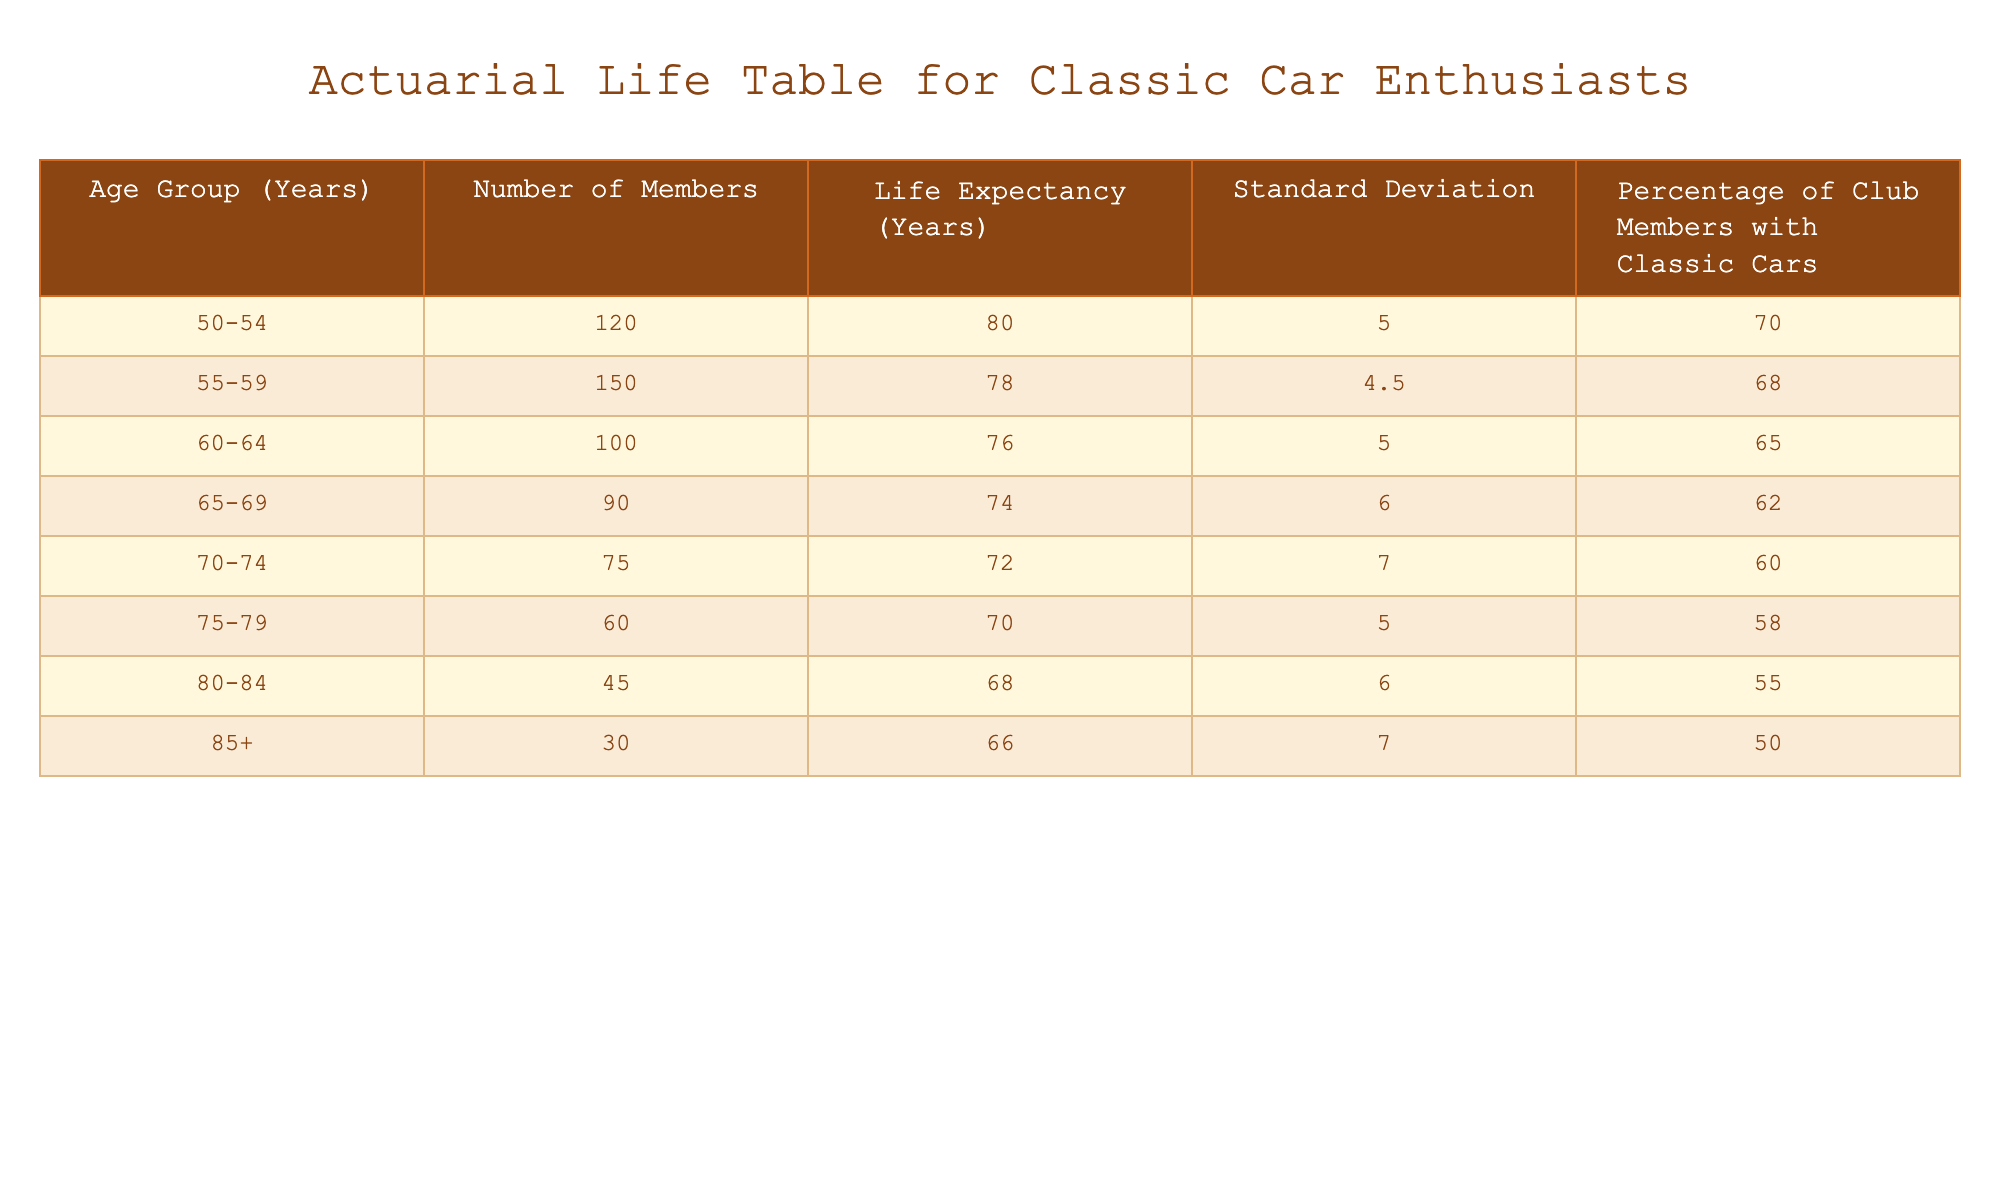What is the life expectancy of members aged 70-74? From the table, we can directly find the row that corresponds to the age group 70-74, which lists a life expectancy of 72 years.
Answer: 72 years How many members are in the 60-64 age group? Referring to the table, the number of members within the 60-64 age group is specified as 100.
Answer: 100 members What is the percentage of club members with classic cars in the 75-79 age group? Looking at the table, for the 75-79 age group, the percentage of club members with classic cars is noted as 58%.
Answer: 58% What is the life expectancy difference between the 50-54 and 85+ age groups? The life expectancy for the 50-54 age group is 80 years, and for the 85+ age group, it is 66 years. The difference is calculated as 80 - 66 = 14 years.
Answer: 14 years Is it true that members in the 80-84 age group have a higher life expectancy than those in the 75-79 age group? Checking the values, the life expectancy for 80-84 is 68 years, while for 75-79 it is 70 years. Thus, the statement is false.
Answer: False What is the average life expectancy of club members aged 55-59 and 60-64? For these age groups, the life expectancies are 78 years (55-59) and 76 years (60-64). The average is calculated as (78 + 76) / 2 = 77 years.
Answer: 77 years For members aged 65-69, what is the standard deviation of life expectancy? The standard deviation for life expectancy in the 65-69 age group is listed as 6 years in the table.
Answer: 6 years What total number of members is there in the age 70-74 and 75-79 groups combined? The number of members in the 70-74 age group is 75, and in the 75-79 age group, it is 60. The total is calculated as 75 + 60 = 135 members.
Answer: 135 members Do a majority of members aged 60-64 own classic cars? The table indicates that 65% of club members in the 60-64 age group own classic cars, which is indeed a majority, since 65% is greater than 50%.
Answer: Yes 